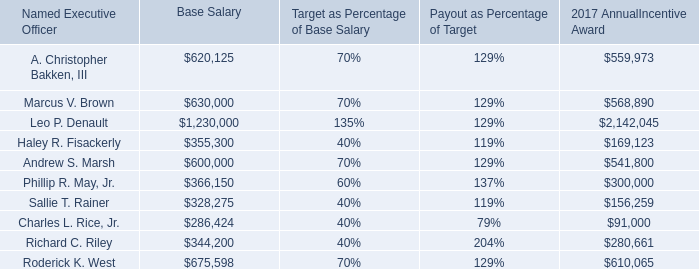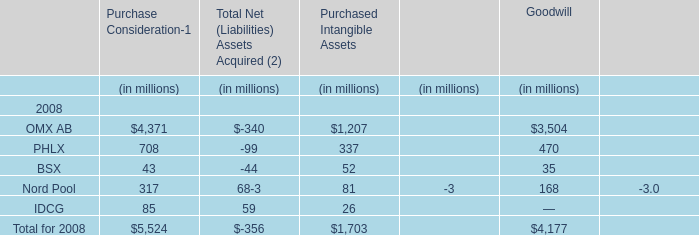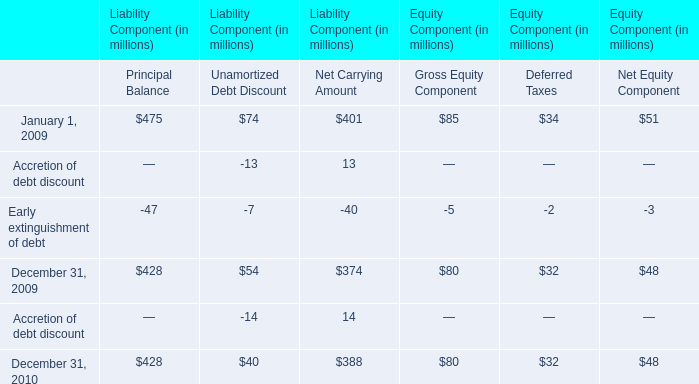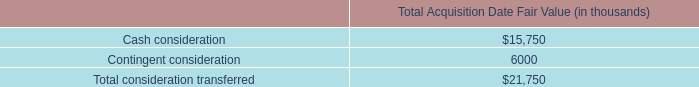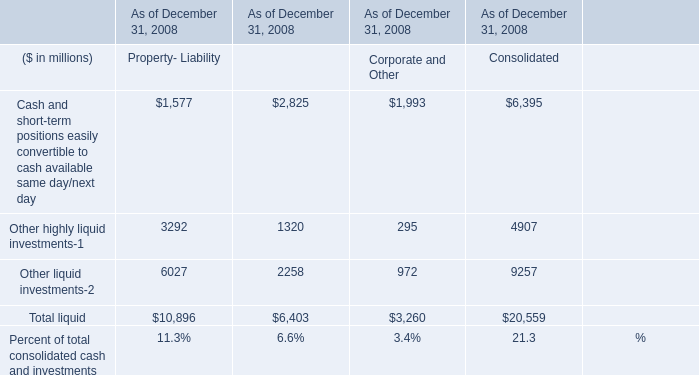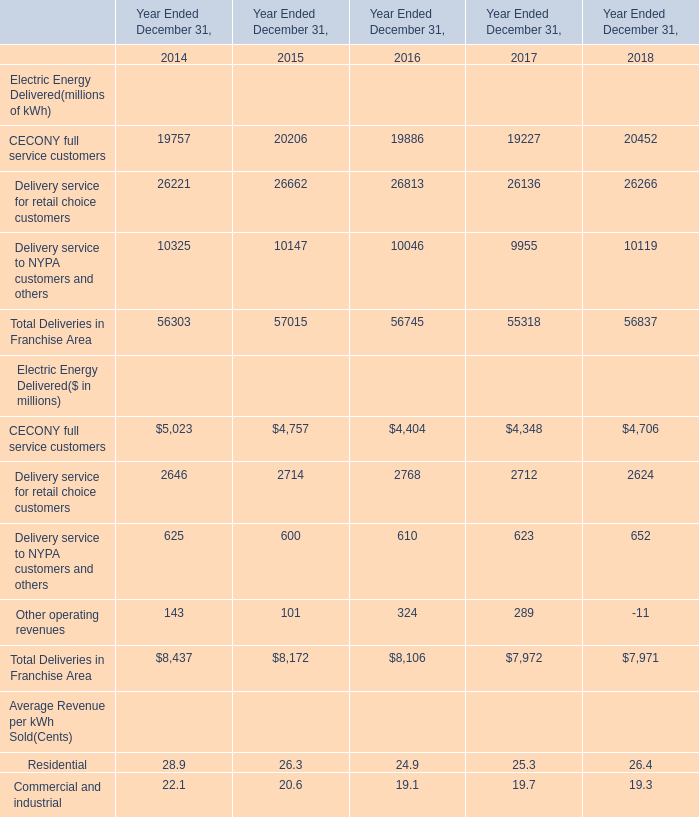What do all Purchase Consideration sum up, excluding those negative ones in 2008 ? (in million) 
Computations: ((((4371 + 708) + 43) + 317) + 85)
Answer: 5524.0. 